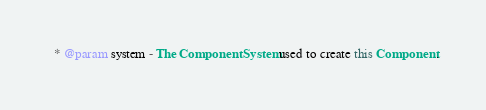Convert code to text. <code><loc_0><loc_0><loc_500><loc_500><_Scala_>  * @param system - The ComponentSystem used to create this Component.</code> 